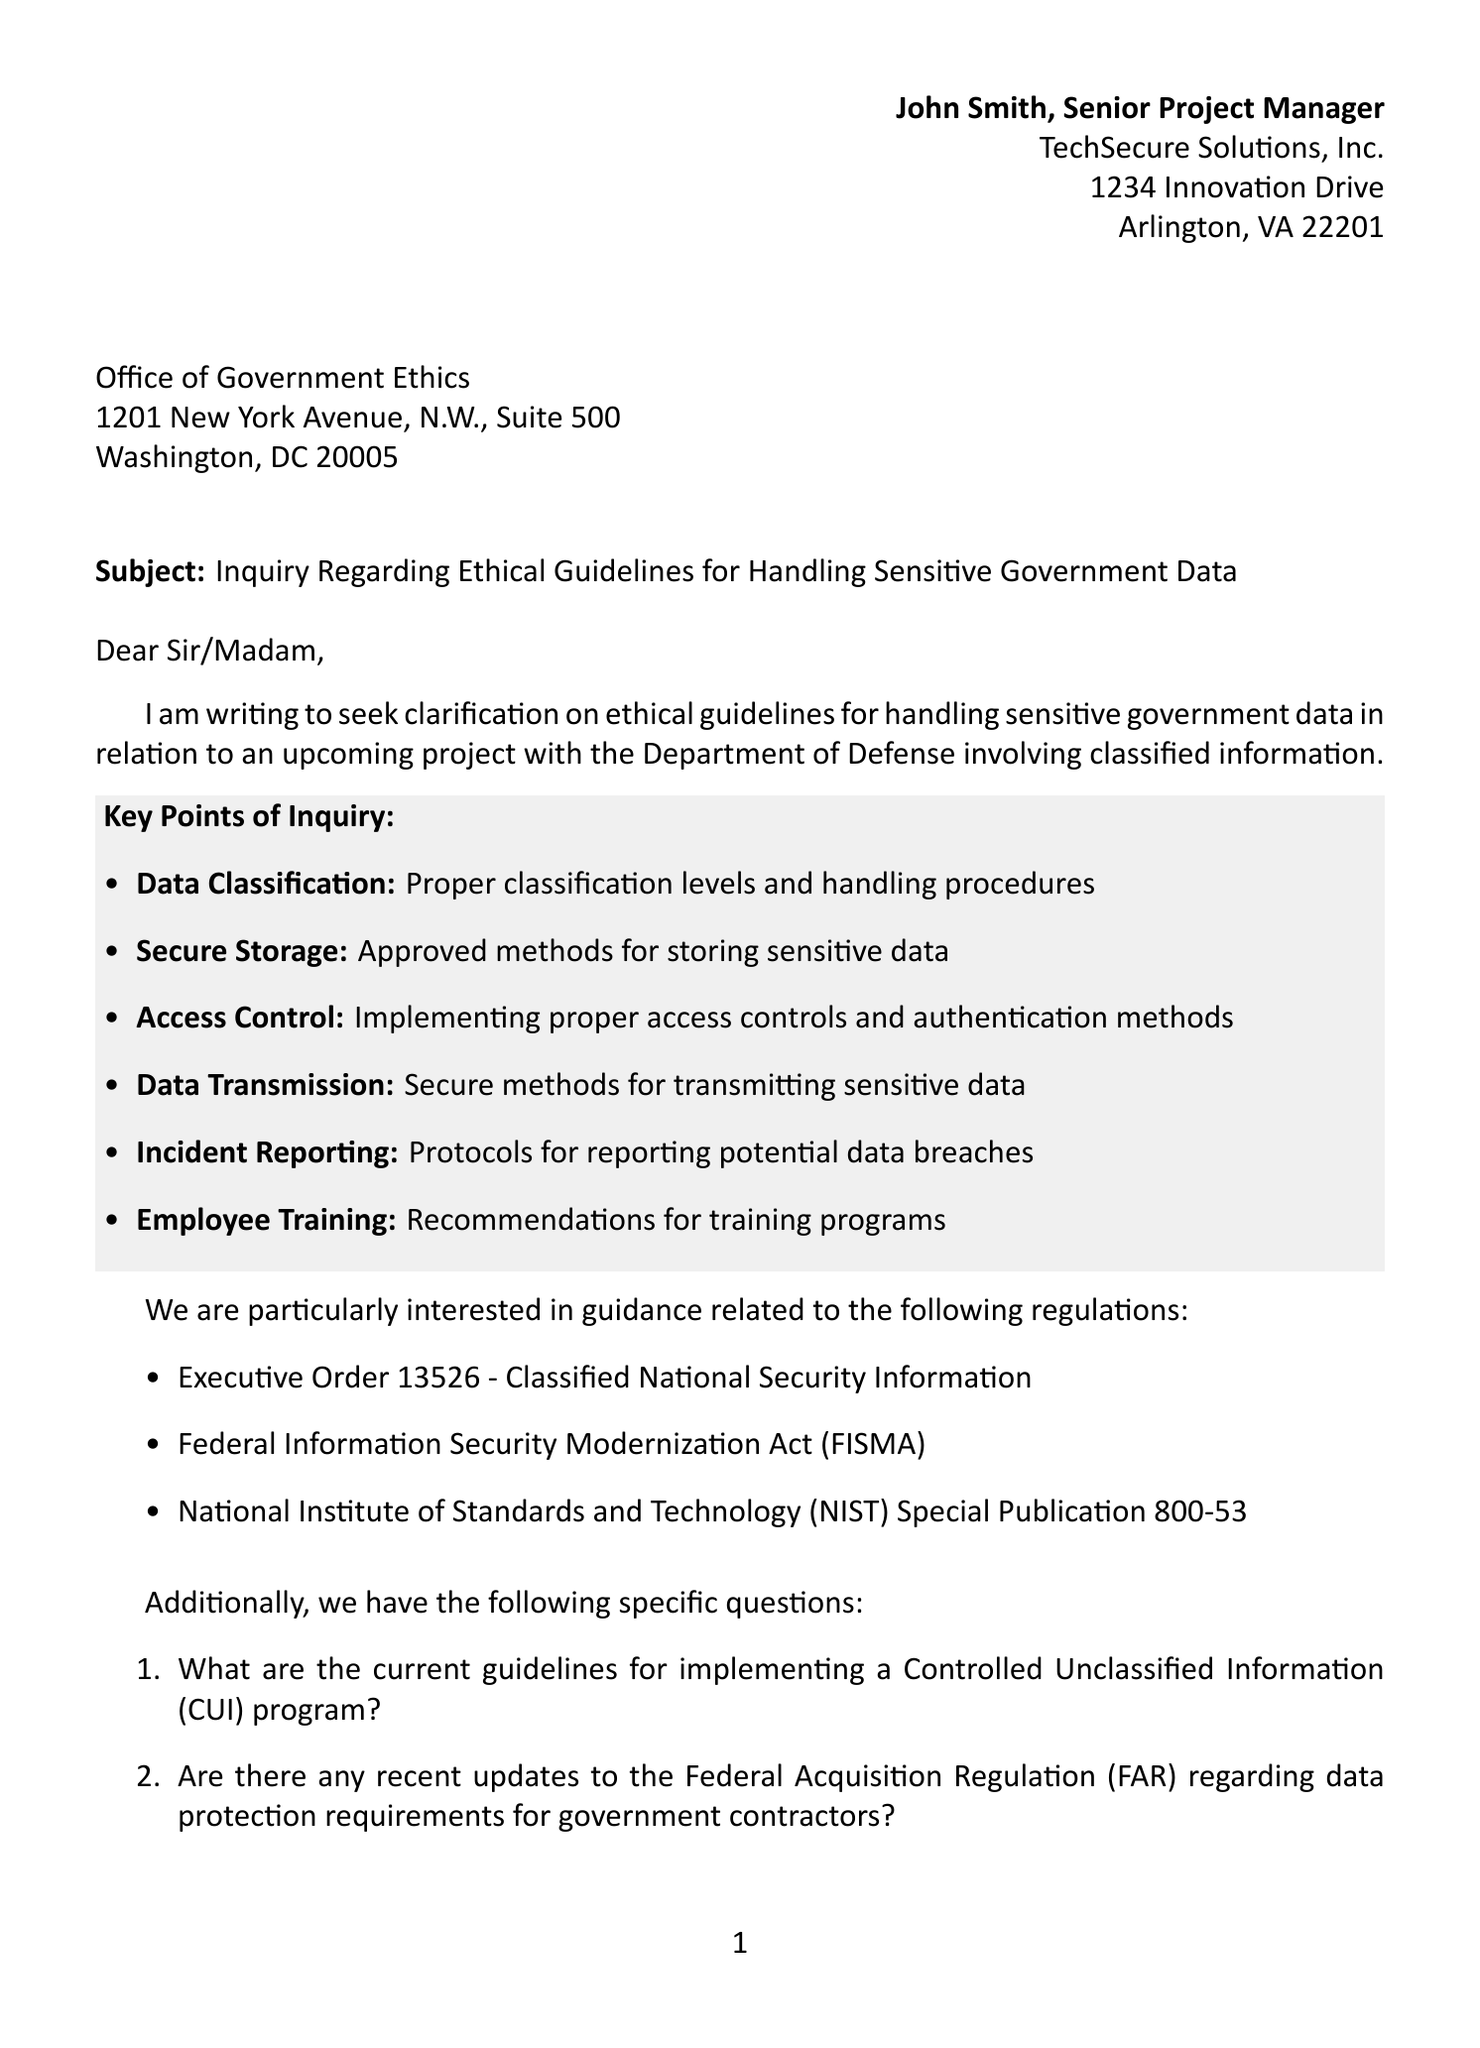What is the sender's name? The sender's name appears at the top of the letter, stating "John Smith."
Answer: John Smith What is the recipient's address? The recipient's address is specified in the letter, detailing "1201 New York Avenue, N.W., Suite 500, Washington, DC 20005."
Answer: 1201 New York Avenue, N.W., Suite 500, Washington, DC 20005 What are the key points of inquiry? The letter lists specific topics of inquiry such as "Data Classification," "Secure Storage," and "Access Control."
Answer: Data Classification, Secure Storage, Access Control, Data Transmission, Incident Reporting, Employee Training What is the subject of the letter? The subject line explicitly states the purpose of the letter: "Inquiry Regarding Ethical Guidelines for Handling Sensitive Government Data."
Answer: Inquiry Regarding Ethical Guidelines for Handling Sensitive Government Data Who is the sender's company? The sender's company is mentioned in the header as "TechSecure Solutions, Inc."
Answer: TechSecure Solutions, Inc What document outlines the ethical standards mentioned? The letter cites "Executive Order 13526 - Classified National Security Information" among relevant regulations.
Answer: Executive Order 13526 - Classified National Security Information What specific question is asked about Artificial Intelligence? The letter includes a specific inquiry about AI, asking, "What are the ethical considerations for using artificial intelligence in processing sensitive government data?"
Answer: What are the ethical considerations for using artificial intelligence in processing sensitive government data? What is the closing commitment made by the sender? The closing statement reaffirms the sender's commitment to ethical standards in handling government data.
Answer: Commitment to maintaining the highest ethical standards in handling government data 